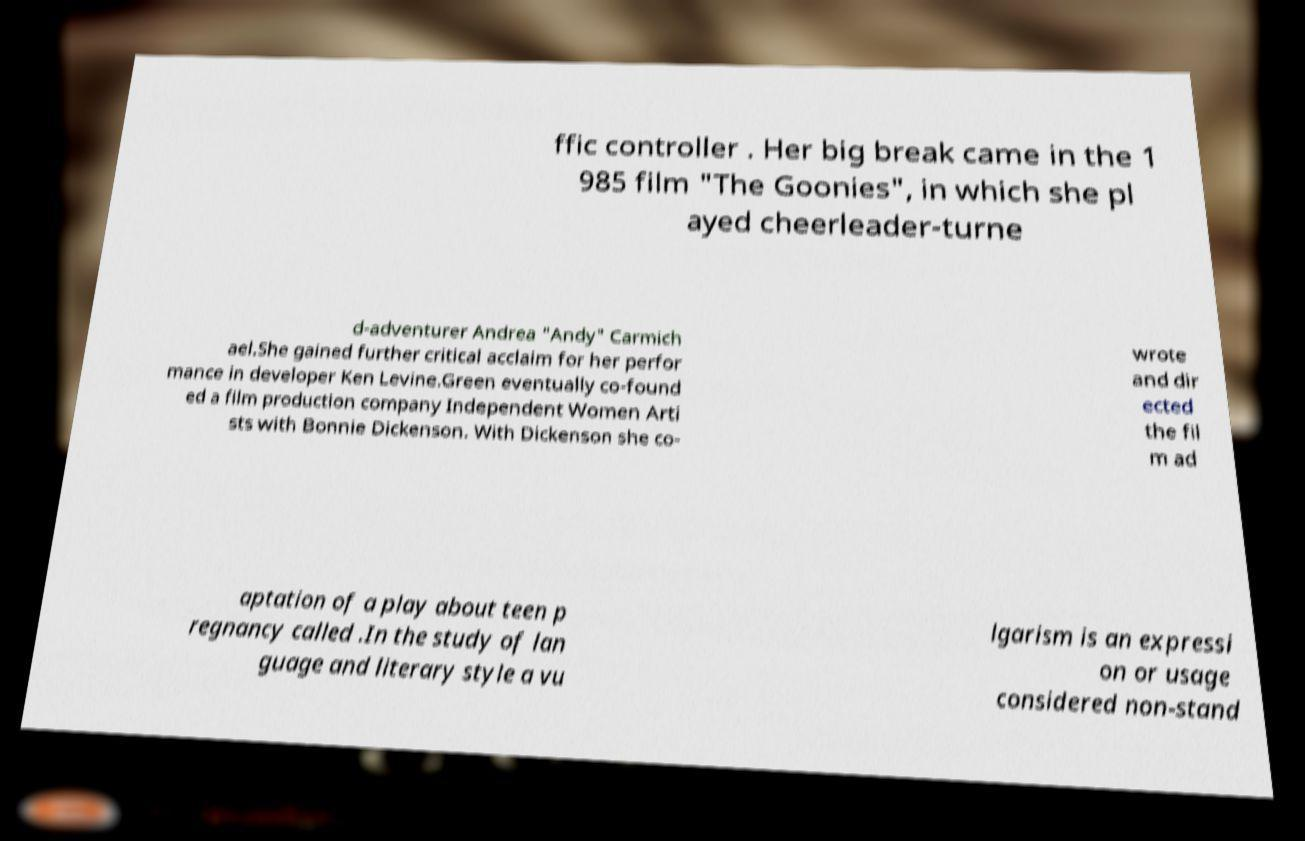There's text embedded in this image that I need extracted. Can you transcribe it verbatim? ffic controller . Her big break came in the 1 985 film "The Goonies", in which she pl ayed cheerleader-turne d-adventurer Andrea "Andy" Carmich ael.She gained further critical acclaim for her perfor mance in developer Ken Levine.Green eventually co-found ed a film production company Independent Women Arti sts with Bonnie Dickenson. With Dickenson she co- wrote and dir ected the fil m ad aptation of a play about teen p regnancy called .In the study of lan guage and literary style a vu lgarism is an expressi on or usage considered non-stand 